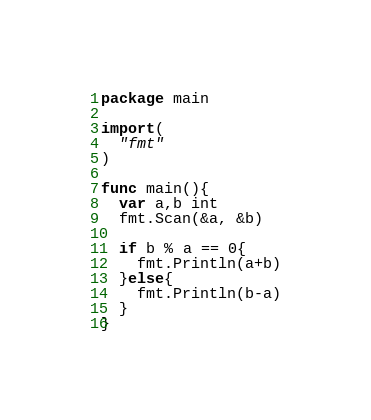Convert code to text. <code><loc_0><loc_0><loc_500><loc_500><_Go_>package main

import(
  "fmt"
)

func main(){
  var a,b int
  fmt.Scan(&a, &b)
  
  if b % a == 0{
    fmt.Println(a+b)
  }else{
    fmt.Println(b-a)
  }
}</code> 